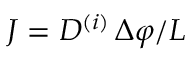Convert formula to latex. <formula><loc_0><loc_0><loc_500><loc_500>J = D ^ { ( i ) } \, \Delta \varphi / L</formula> 